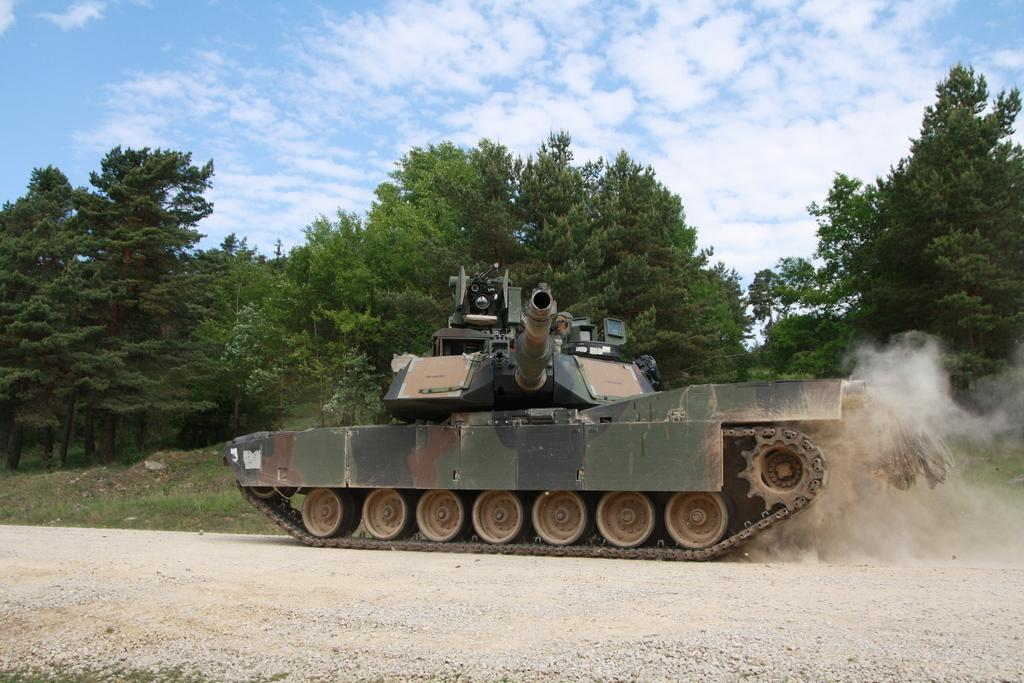What is on the road in the image? There is a vehicle on the road in the image. What type of vegetation can be seen in the image? There are trees and grass in the image. What is visible in the background of the image? The sky is visible in the background of the image. How many rings are visible on the vehicle in the image? There are no rings visible on the vehicle in the image. Are there any ants crawling on the grass in the image? There is no indication of ants in the image; it only shows a vehicle on the road, trees, grass, and the sky. 